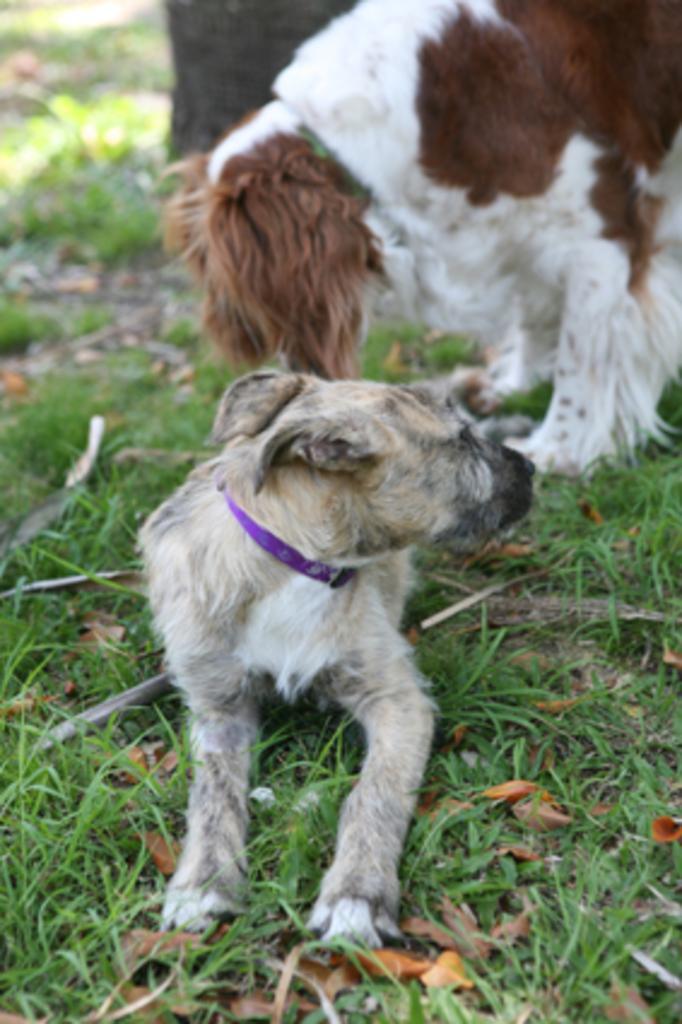In one or two sentences, can you explain what this image depicts? In the foreground of this image, there is a dog sitting on the grass and a dog behind is standing. In the background, there is a tree trunk. 